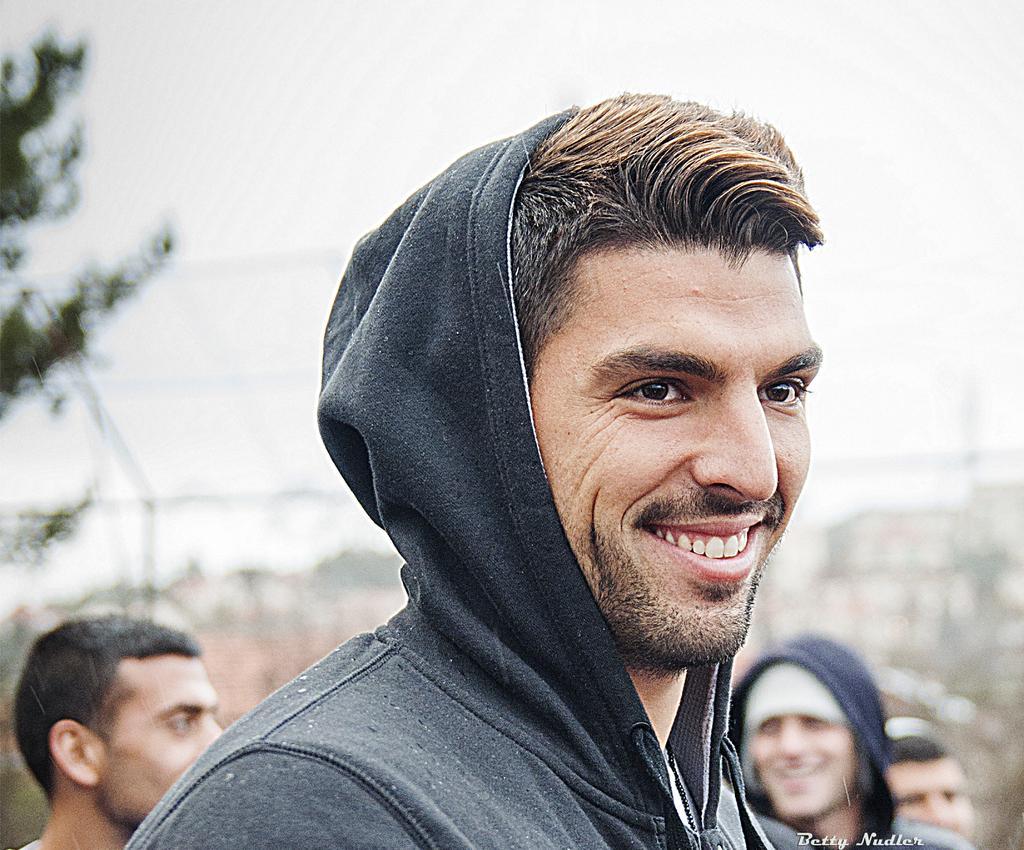How would you summarize this image in a sentence or two? In this image there are group of persons truncated towards the bottom of the image, there is text towards the bottom of the image, there is a tree truncated towards the left of the image, the background of the image is blurred. 